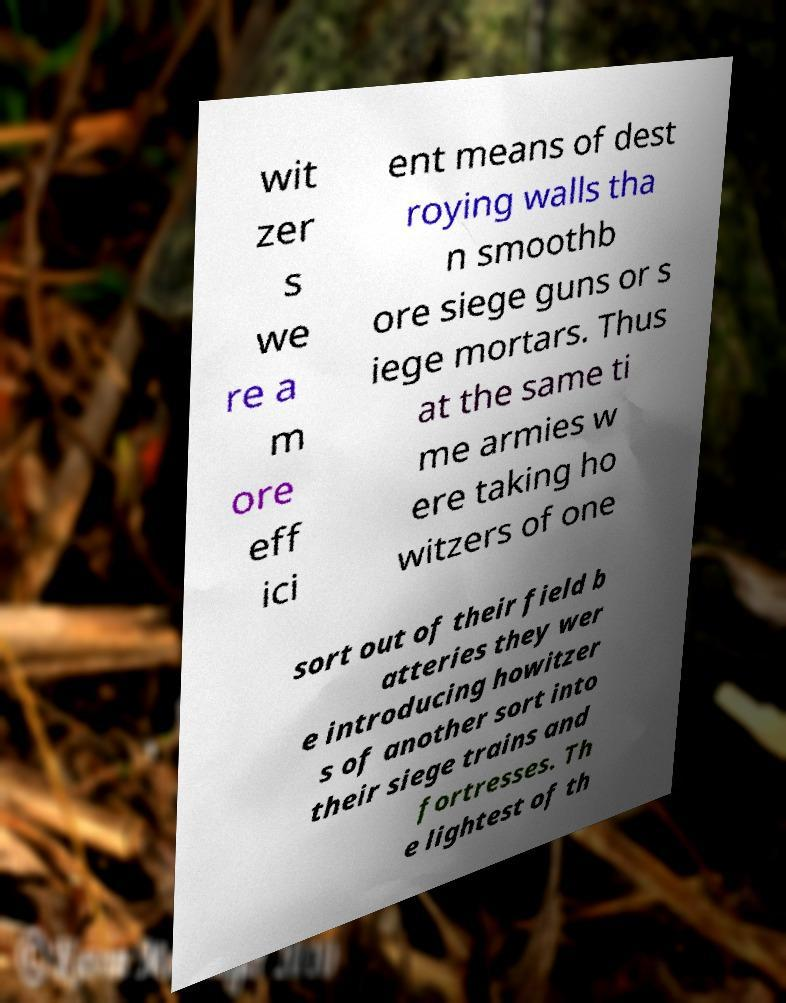Please read and relay the text visible in this image. What does it say? wit zer s we re a m ore eff ici ent means of dest roying walls tha n smoothb ore siege guns or s iege mortars. Thus at the same ti me armies w ere taking ho witzers of one sort out of their field b atteries they wer e introducing howitzer s of another sort into their siege trains and fortresses. Th e lightest of th 